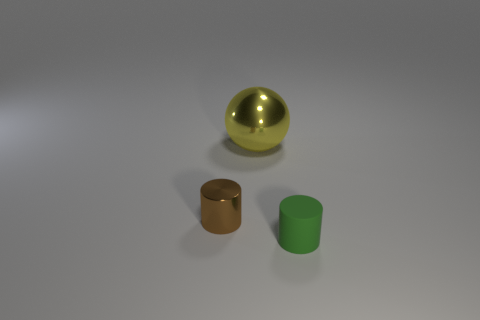Add 1 tiny cylinders. How many objects exist? 4 Subtract 2 cylinders. How many cylinders are left? 0 Subtract all red cylinders. Subtract all yellow spheres. How many cylinders are left? 2 Subtract all gray spheres. How many purple cylinders are left? 0 Subtract all green matte cylinders. Subtract all large yellow things. How many objects are left? 1 Add 3 small metallic cylinders. How many small metallic cylinders are left? 4 Add 1 tiny brown objects. How many tiny brown objects exist? 2 Subtract all brown cylinders. How many cylinders are left? 1 Subtract 1 yellow spheres. How many objects are left? 2 Subtract all cylinders. How many objects are left? 1 